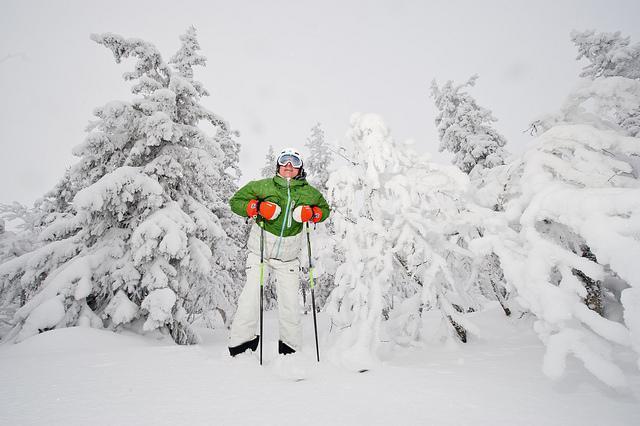How many chairs are shown?
Give a very brief answer. 0. 